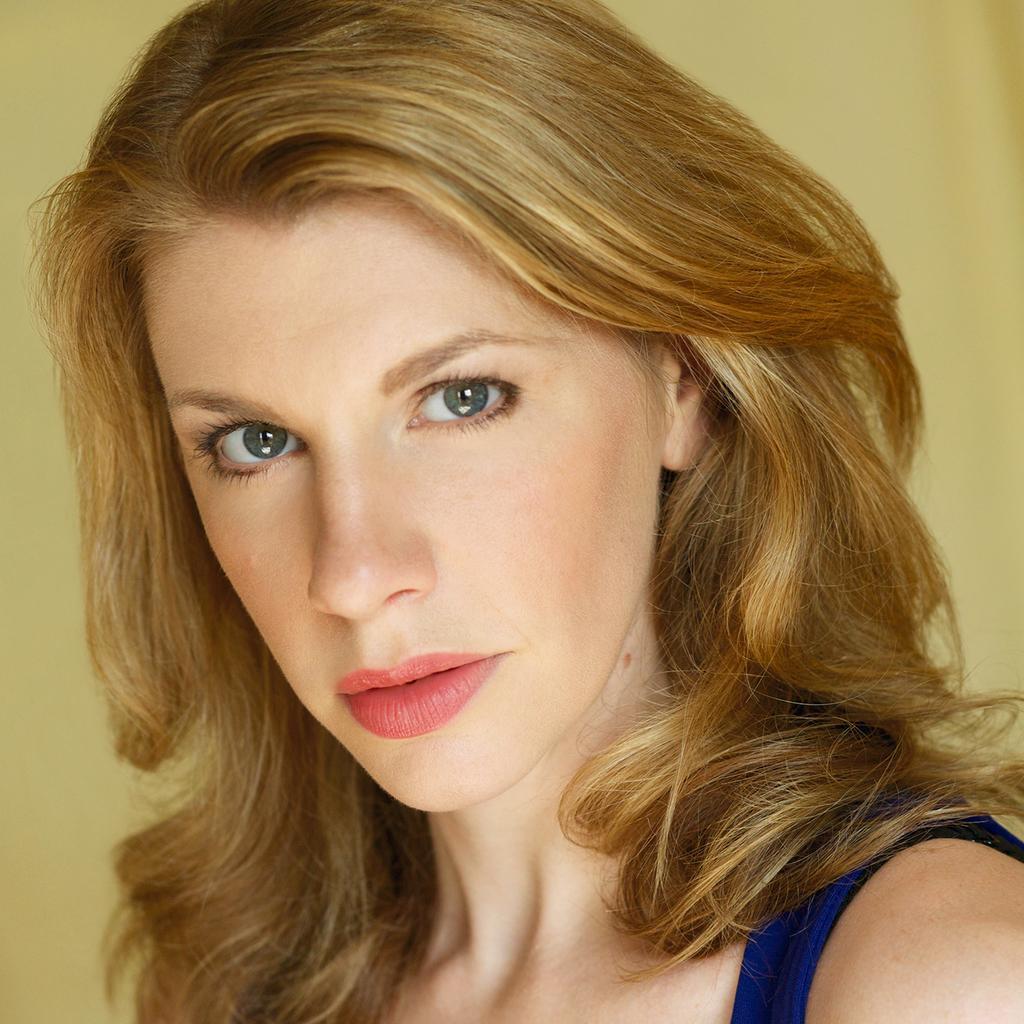Please provide a concise description of this image. In the foreground of this image, there is a woman with blonde hair and a creamy texture in the background. 